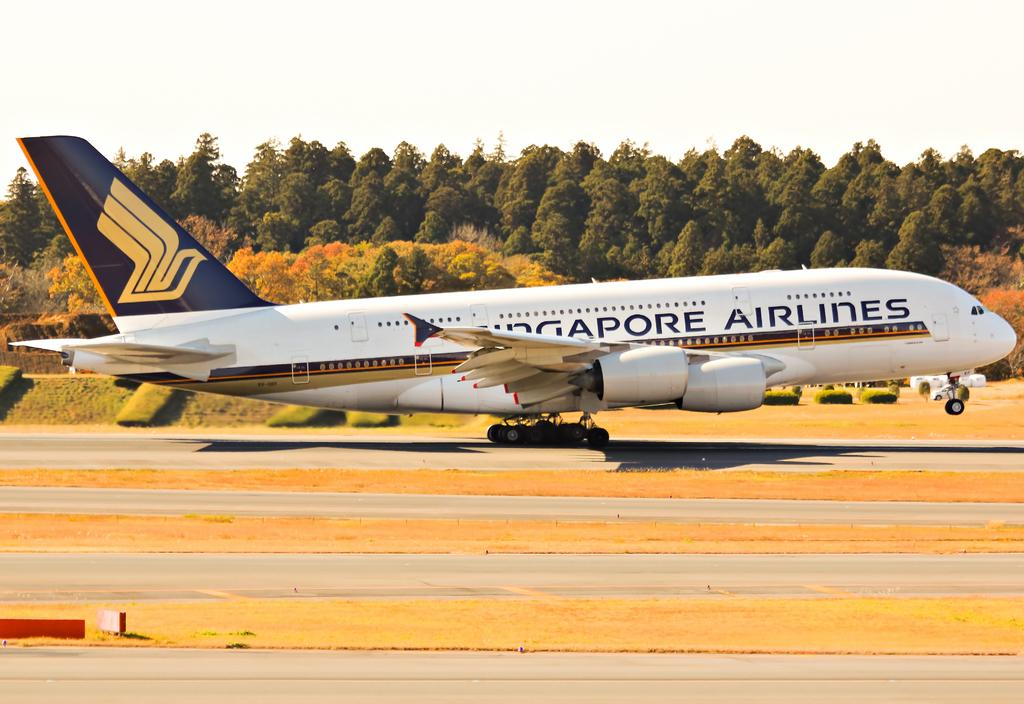What is the main subject of the image? The main subject of the image is an airplane. What can be seen at the bottom of the image? There are roads at the bottom of the image. What type of vegetation is visible on the ground? Grass is visible on the ground. What is in the background of the image? There are trees in the background of the image. What is visible at the top of the image? The sky is visible at the top of the image. How many beads are scattered on the grass in the image? There are no beads present in the image; it features an airplane, roads, grass, trees, and the sky. Can you see the toes of the passengers on the airplane in the image? There is no indication of passengers or their toes in the image, as it only shows the airplane, roads, grass, trees, and the sky. 